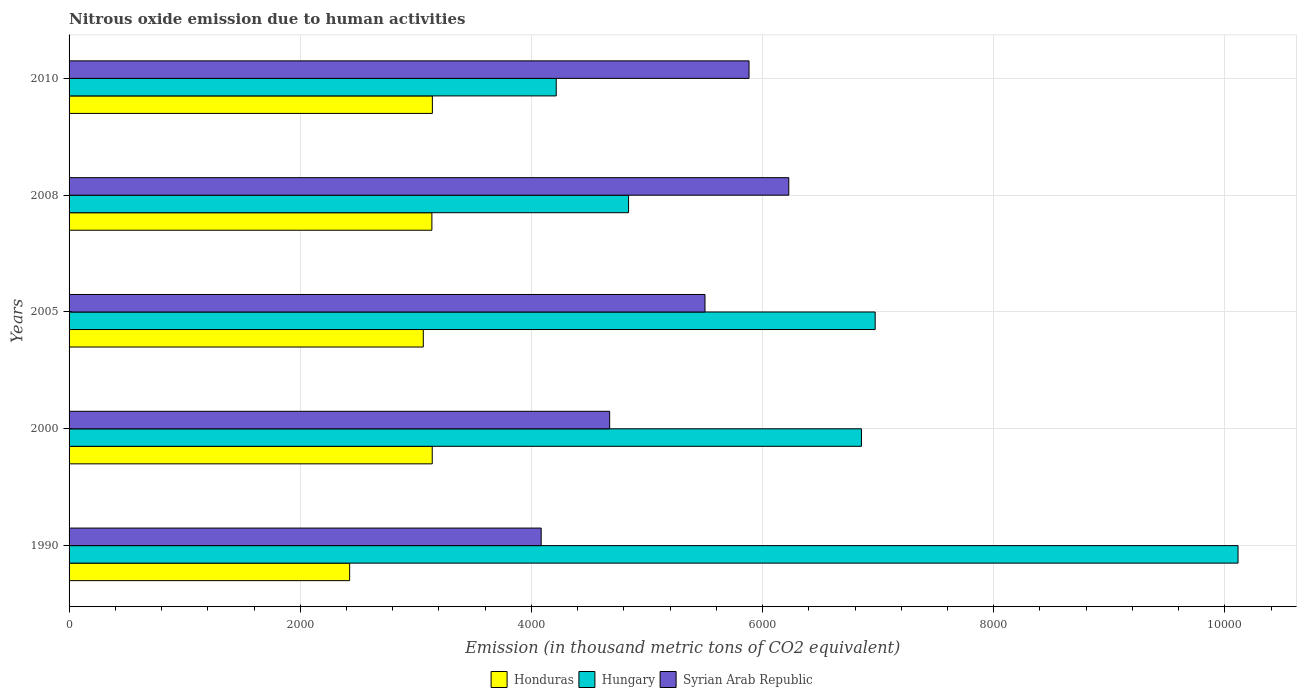How many different coloured bars are there?
Ensure brevity in your answer.  3. What is the label of the 2nd group of bars from the top?
Your answer should be very brief. 2008. What is the amount of nitrous oxide emitted in Honduras in 2000?
Give a very brief answer. 3142.2. Across all years, what is the maximum amount of nitrous oxide emitted in Hungary?
Your answer should be very brief. 1.01e+04. Across all years, what is the minimum amount of nitrous oxide emitted in Hungary?
Give a very brief answer. 4215.1. In which year was the amount of nitrous oxide emitted in Hungary minimum?
Keep it short and to the point. 2010. What is the total amount of nitrous oxide emitted in Honduras in the graph?
Provide a succinct answer. 1.49e+04. What is the difference between the amount of nitrous oxide emitted in Hungary in 1990 and that in 2008?
Give a very brief answer. 5273.4. What is the difference between the amount of nitrous oxide emitted in Hungary in 1990 and the amount of nitrous oxide emitted in Syrian Arab Republic in 2005?
Provide a short and direct response. 4612. What is the average amount of nitrous oxide emitted in Hungary per year?
Your response must be concise. 6600.1. In the year 2005, what is the difference between the amount of nitrous oxide emitted in Syrian Arab Republic and amount of nitrous oxide emitted in Hungary?
Provide a short and direct response. -1472.4. What is the ratio of the amount of nitrous oxide emitted in Honduras in 2000 to that in 2005?
Provide a short and direct response. 1.03. What is the difference between the highest and the second highest amount of nitrous oxide emitted in Honduras?
Offer a very short reply. 1.2. What is the difference between the highest and the lowest amount of nitrous oxide emitted in Syrian Arab Republic?
Ensure brevity in your answer.  2142.3. In how many years, is the amount of nitrous oxide emitted in Syrian Arab Republic greater than the average amount of nitrous oxide emitted in Syrian Arab Republic taken over all years?
Give a very brief answer. 3. Is the sum of the amount of nitrous oxide emitted in Syrian Arab Republic in 2000 and 2005 greater than the maximum amount of nitrous oxide emitted in Honduras across all years?
Make the answer very short. Yes. What does the 1st bar from the top in 2000 represents?
Offer a very short reply. Syrian Arab Republic. What does the 3rd bar from the bottom in 2005 represents?
Provide a succinct answer. Syrian Arab Republic. Are all the bars in the graph horizontal?
Your response must be concise. Yes. Are the values on the major ticks of X-axis written in scientific E-notation?
Keep it short and to the point. No. Does the graph contain any zero values?
Provide a succinct answer. No. Where does the legend appear in the graph?
Give a very brief answer. Bottom center. How many legend labels are there?
Make the answer very short. 3. What is the title of the graph?
Offer a terse response. Nitrous oxide emission due to human activities. Does "Bolivia" appear as one of the legend labels in the graph?
Keep it short and to the point. No. What is the label or title of the X-axis?
Provide a succinct answer. Emission (in thousand metric tons of CO2 equivalent). What is the Emission (in thousand metric tons of CO2 equivalent) in Honduras in 1990?
Your answer should be compact. 2427.6. What is the Emission (in thousand metric tons of CO2 equivalent) of Hungary in 1990?
Your response must be concise. 1.01e+04. What is the Emission (in thousand metric tons of CO2 equivalent) in Syrian Arab Republic in 1990?
Offer a terse response. 4084.8. What is the Emission (in thousand metric tons of CO2 equivalent) in Honduras in 2000?
Your answer should be compact. 3142.2. What is the Emission (in thousand metric tons of CO2 equivalent) of Hungary in 2000?
Provide a short and direct response. 6855.8. What is the Emission (in thousand metric tons of CO2 equivalent) of Syrian Arab Republic in 2000?
Provide a short and direct response. 4677.3. What is the Emission (in thousand metric tons of CO2 equivalent) in Honduras in 2005?
Keep it short and to the point. 3064.9. What is the Emission (in thousand metric tons of CO2 equivalent) of Hungary in 2005?
Offer a very short reply. 6974.6. What is the Emission (in thousand metric tons of CO2 equivalent) of Syrian Arab Republic in 2005?
Your answer should be compact. 5502.2. What is the Emission (in thousand metric tons of CO2 equivalent) of Honduras in 2008?
Give a very brief answer. 3139.2. What is the Emission (in thousand metric tons of CO2 equivalent) of Hungary in 2008?
Provide a succinct answer. 4840.8. What is the Emission (in thousand metric tons of CO2 equivalent) in Syrian Arab Republic in 2008?
Your answer should be compact. 6227.1. What is the Emission (in thousand metric tons of CO2 equivalent) of Honduras in 2010?
Your answer should be very brief. 3143.4. What is the Emission (in thousand metric tons of CO2 equivalent) in Hungary in 2010?
Offer a very short reply. 4215.1. What is the Emission (in thousand metric tons of CO2 equivalent) of Syrian Arab Republic in 2010?
Give a very brief answer. 5883.1. Across all years, what is the maximum Emission (in thousand metric tons of CO2 equivalent) of Honduras?
Give a very brief answer. 3143.4. Across all years, what is the maximum Emission (in thousand metric tons of CO2 equivalent) in Hungary?
Make the answer very short. 1.01e+04. Across all years, what is the maximum Emission (in thousand metric tons of CO2 equivalent) of Syrian Arab Republic?
Offer a terse response. 6227.1. Across all years, what is the minimum Emission (in thousand metric tons of CO2 equivalent) in Honduras?
Ensure brevity in your answer.  2427.6. Across all years, what is the minimum Emission (in thousand metric tons of CO2 equivalent) in Hungary?
Provide a succinct answer. 4215.1. Across all years, what is the minimum Emission (in thousand metric tons of CO2 equivalent) of Syrian Arab Republic?
Your answer should be very brief. 4084.8. What is the total Emission (in thousand metric tons of CO2 equivalent) in Honduras in the graph?
Provide a succinct answer. 1.49e+04. What is the total Emission (in thousand metric tons of CO2 equivalent) in Hungary in the graph?
Provide a short and direct response. 3.30e+04. What is the total Emission (in thousand metric tons of CO2 equivalent) of Syrian Arab Republic in the graph?
Give a very brief answer. 2.64e+04. What is the difference between the Emission (in thousand metric tons of CO2 equivalent) in Honduras in 1990 and that in 2000?
Give a very brief answer. -714.6. What is the difference between the Emission (in thousand metric tons of CO2 equivalent) of Hungary in 1990 and that in 2000?
Ensure brevity in your answer.  3258.4. What is the difference between the Emission (in thousand metric tons of CO2 equivalent) of Syrian Arab Republic in 1990 and that in 2000?
Your response must be concise. -592.5. What is the difference between the Emission (in thousand metric tons of CO2 equivalent) in Honduras in 1990 and that in 2005?
Provide a short and direct response. -637.3. What is the difference between the Emission (in thousand metric tons of CO2 equivalent) in Hungary in 1990 and that in 2005?
Your answer should be very brief. 3139.6. What is the difference between the Emission (in thousand metric tons of CO2 equivalent) of Syrian Arab Republic in 1990 and that in 2005?
Make the answer very short. -1417.4. What is the difference between the Emission (in thousand metric tons of CO2 equivalent) of Honduras in 1990 and that in 2008?
Your answer should be very brief. -711.6. What is the difference between the Emission (in thousand metric tons of CO2 equivalent) in Hungary in 1990 and that in 2008?
Your response must be concise. 5273.4. What is the difference between the Emission (in thousand metric tons of CO2 equivalent) of Syrian Arab Republic in 1990 and that in 2008?
Ensure brevity in your answer.  -2142.3. What is the difference between the Emission (in thousand metric tons of CO2 equivalent) in Honduras in 1990 and that in 2010?
Your response must be concise. -715.8. What is the difference between the Emission (in thousand metric tons of CO2 equivalent) in Hungary in 1990 and that in 2010?
Offer a very short reply. 5899.1. What is the difference between the Emission (in thousand metric tons of CO2 equivalent) in Syrian Arab Republic in 1990 and that in 2010?
Your response must be concise. -1798.3. What is the difference between the Emission (in thousand metric tons of CO2 equivalent) in Honduras in 2000 and that in 2005?
Make the answer very short. 77.3. What is the difference between the Emission (in thousand metric tons of CO2 equivalent) in Hungary in 2000 and that in 2005?
Keep it short and to the point. -118.8. What is the difference between the Emission (in thousand metric tons of CO2 equivalent) in Syrian Arab Republic in 2000 and that in 2005?
Provide a short and direct response. -824.9. What is the difference between the Emission (in thousand metric tons of CO2 equivalent) in Hungary in 2000 and that in 2008?
Your answer should be very brief. 2015. What is the difference between the Emission (in thousand metric tons of CO2 equivalent) of Syrian Arab Republic in 2000 and that in 2008?
Provide a succinct answer. -1549.8. What is the difference between the Emission (in thousand metric tons of CO2 equivalent) in Hungary in 2000 and that in 2010?
Offer a very short reply. 2640.7. What is the difference between the Emission (in thousand metric tons of CO2 equivalent) of Syrian Arab Republic in 2000 and that in 2010?
Offer a very short reply. -1205.8. What is the difference between the Emission (in thousand metric tons of CO2 equivalent) in Honduras in 2005 and that in 2008?
Offer a very short reply. -74.3. What is the difference between the Emission (in thousand metric tons of CO2 equivalent) in Hungary in 2005 and that in 2008?
Your answer should be very brief. 2133.8. What is the difference between the Emission (in thousand metric tons of CO2 equivalent) of Syrian Arab Republic in 2005 and that in 2008?
Provide a succinct answer. -724.9. What is the difference between the Emission (in thousand metric tons of CO2 equivalent) in Honduras in 2005 and that in 2010?
Ensure brevity in your answer.  -78.5. What is the difference between the Emission (in thousand metric tons of CO2 equivalent) in Hungary in 2005 and that in 2010?
Make the answer very short. 2759.5. What is the difference between the Emission (in thousand metric tons of CO2 equivalent) of Syrian Arab Republic in 2005 and that in 2010?
Ensure brevity in your answer.  -380.9. What is the difference between the Emission (in thousand metric tons of CO2 equivalent) of Honduras in 2008 and that in 2010?
Give a very brief answer. -4.2. What is the difference between the Emission (in thousand metric tons of CO2 equivalent) in Hungary in 2008 and that in 2010?
Provide a succinct answer. 625.7. What is the difference between the Emission (in thousand metric tons of CO2 equivalent) of Syrian Arab Republic in 2008 and that in 2010?
Provide a short and direct response. 344. What is the difference between the Emission (in thousand metric tons of CO2 equivalent) in Honduras in 1990 and the Emission (in thousand metric tons of CO2 equivalent) in Hungary in 2000?
Your answer should be compact. -4428.2. What is the difference between the Emission (in thousand metric tons of CO2 equivalent) in Honduras in 1990 and the Emission (in thousand metric tons of CO2 equivalent) in Syrian Arab Republic in 2000?
Your response must be concise. -2249.7. What is the difference between the Emission (in thousand metric tons of CO2 equivalent) in Hungary in 1990 and the Emission (in thousand metric tons of CO2 equivalent) in Syrian Arab Republic in 2000?
Keep it short and to the point. 5436.9. What is the difference between the Emission (in thousand metric tons of CO2 equivalent) in Honduras in 1990 and the Emission (in thousand metric tons of CO2 equivalent) in Hungary in 2005?
Offer a terse response. -4547. What is the difference between the Emission (in thousand metric tons of CO2 equivalent) in Honduras in 1990 and the Emission (in thousand metric tons of CO2 equivalent) in Syrian Arab Republic in 2005?
Your response must be concise. -3074.6. What is the difference between the Emission (in thousand metric tons of CO2 equivalent) in Hungary in 1990 and the Emission (in thousand metric tons of CO2 equivalent) in Syrian Arab Republic in 2005?
Offer a very short reply. 4612. What is the difference between the Emission (in thousand metric tons of CO2 equivalent) in Honduras in 1990 and the Emission (in thousand metric tons of CO2 equivalent) in Hungary in 2008?
Keep it short and to the point. -2413.2. What is the difference between the Emission (in thousand metric tons of CO2 equivalent) of Honduras in 1990 and the Emission (in thousand metric tons of CO2 equivalent) of Syrian Arab Republic in 2008?
Give a very brief answer. -3799.5. What is the difference between the Emission (in thousand metric tons of CO2 equivalent) in Hungary in 1990 and the Emission (in thousand metric tons of CO2 equivalent) in Syrian Arab Republic in 2008?
Keep it short and to the point. 3887.1. What is the difference between the Emission (in thousand metric tons of CO2 equivalent) in Honduras in 1990 and the Emission (in thousand metric tons of CO2 equivalent) in Hungary in 2010?
Give a very brief answer. -1787.5. What is the difference between the Emission (in thousand metric tons of CO2 equivalent) in Honduras in 1990 and the Emission (in thousand metric tons of CO2 equivalent) in Syrian Arab Republic in 2010?
Offer a terse response. -3455.5. What is the difference between the Emission (in thousand metric tons of CO2 equivalent) in Hungary in 1990 and the Emission (in thousand metric tons of CO2 equivalent) in Syrian Arab Republic in 2010?
Ensure brevity in your answer.  4231.1. What is the difference between the Emission (in thousand metric tons of CO2 equivalent) in Honduras in 2000 and the Emission (in thousand metric tons of CO2 equivalent) in Hungary in 2005?
Keep it short and to the point. -3832.4. What is the difference between the Emission (in thousand metric tons of CO2 equivalent) of Honduras in 2000 and the Emission (in thousand metric tons of CO2 equivalent) of Syrian Arab Republic in 2005?
Keep it short and to the point. -2360. What is the difference between the Emission (in thousand metric tons of CO2 equivalent) of Hungary in 2000 and the Emission (in thousand metric tons of CO2 equivalent) of Syrian Arab Republic in 2005?
Keep it short and to the point. 1353.6. What is the difference between the Emission (in thousand metric tons of CO2 equivalent) in Honduras in 2000 and the Emission (in thousand metric tons of CO2 equivalent) in Hungary in 2008?
Your answer should be very brief. -1698.6. What is the difference between the Emission (in thousand metric tons of CO2 equivalent) of Honduras in 2000 and the Emission (in thousand metric tons of CO2 equivalent) of Syrian Arab Republic in 2008?
Your response must be concise. -3084.9. What is the difference between the Emission (in thousand metric tons of CO2 equivalent) in Hungary in 2000 and the Emission (in thousand metric tons of CO2 equivalent) in Syrian Arab Republic in 2008?
Your answer should be very brief. 628.7. What is the difference between the Emission (in thousand metric tons of CO2 equivalent) in Honduras in 2000 and the Emission (in thousand metric tons of CO2 equivalent) in Hungary in 2010?
Keep it short and to the point. -1072.9. What is the difference between the Emission (in thousand metric tons of CO2 equivalent) in Honduras in 2000 and the Emission (in thousand metric tons of CO2 equivalent) in Syrian Arab Republic in 2010?
Your answer should be compact. -2740.9. What is the difference between the Emission (in thousand metric tons of CO2 equivalent) in Hungary in 2000 and the Emission (in thousand metric tons of CO2 equivalent) in Syrian Arab Republic in 2010?
Make the answer very short. 972.7. What is the difference between the Emission (in thousand metric tons of CO2 equivalent) in Honduras in 2005 and the Emission (in thousand metric tons of CO2 equivalent) in Hungary in 2008?
Make the answer very short. -1775.9. What is the difference between the Emission (in thousand metric tons of CO2 equivalent) in Honduras in 2005 and the Emission (in thousand metric tons of CO2 equivalent) in Syrian Arab Republic in 2008?
Ensure brevity in your answer.  -3162.2. What is the difference between the Emission (in thousand metric tons of CO2 equivalent) of Hungary in 2005 and the Emission (in thousand metric tons of CO2 equivalent) of Syrian Arab Republic in 2008?
Provide a short and direct response. 747.5. What is the difference between the Emission (in thousand metric tons of CO2 equivalent) of Honduras in 2005 and the Emission (in thousand metric tons of CO2 equivalent) of Hungary in 2010?
Provide a succinct answer. -1150.2. What is the difference between the Emission (in thousand metric tons of CO2 equivalent) of Honduras in 2005 and the Emission (in thousand metric tons of CO2 equivalent) of Syrian Arab Republic in 2010?
Offer a terse response. -2818.2. What is the difference between the Emission (in thousand metric tons of CO2 equivalent) in Hungary in 2005 and the Emission (in thousand metric tons of CO2 equivalent) in Syrian Arab Republic in 2010?
Provide a succinct answer. 1091.5. What is the difference between the Emission (in thousand metric tons of CO2 equivalent) in Honduras in 2008 and the Emission (in thousand metric tons of CO2 equivalent) in Hungary in 2010?
Your answer should be compact. -1075.9. What is the difference between the Emission (in thousand metric tons of CO2 equivalent) in Honduras in 2008 and the Emission (in thousand metric tons of CO2 equivalent) in Syrian Arab Republic in 2010?
Give a very brief answer. -2743.9. What is the difference between the Emission (in thousand metric tons of CO2 equivalent) in Hungary in 2008 and the Emission (in thousand metric tons of CO2 equivalent) in Syrian Arab Republic in 2010?
Provide a succinct answer. -1042.3. What is the average Emission (in thousand metric tons of CO2 equivalent) in Honduras per year?
Offer a very short reply. 2983.46. What is the average Emission (in thousand metric tons of CO2 equivalent) of Hungary per year?
Your response must be concise. 6600.1. What is the average Emission (in thousand metric tons of CO2 equivalent) in Syrian Arab Republic per year?
Ensure brevity in your answer.  5274.9. In the year 1990, what is the difference between the Emission (in thousand metric tons of CO2 equivalent) in Honduras and Emission (in thousand metric tons of CO2 equivalent) in Hungary?
Ensure brevity in your answer.  -7686.6. In the year 1990, what is the difference between the Emission (in thousand metric tons of CO2 equivalent) in Honduras and Emission (in thousand metric tons of CO2 equivalent) in Syrian Arab Republic?
Your response must be concise. -1657.2. In the year 1990, what is the difference between the Emission (in thousand metric tons of CO2 equivalent) in Hungary and Emission (in thousand metric tons of CO2 equivalent) in Syrian Arab Republic?
Keep it short and to the point. 6029.4. In the year 2000, what is the difference between the Emission (in thousand metric tons of CO2 equivalent) in Honduras and Emission (in thousand metric tons of CO2 equivalent) in Hungary?
Provide a succinct answer. -3713.6. In the year 2000, what is the difference between the Emission (in thousand metric tons of CO2 equivalent) of Honduras and Emission (in thousand metric tons of CO2 equivalent) of Syrian Arab Republic?
Offer a very short reply. -1535.1. In the year 2000, what is the difference between the Emission (in thousand metric tons of CO2 equivalent) of Hungary and Emission (in thousand metric tons of CO2 equivalent) of Syrian Arab Republic?
Your response must be concise. 2178.5. In the year 2005, what is the difference between the Emission (in thousand metric tons of CO2 equivalent) of Honduras and Emission (in thousand metric tons of CO2 equivalent) of Hungary?
Ensure brevity in your answer.  -3909.7. In the year 2005, what is the difference between the Emission (in thousand metric tons of CO2 equivalent) in Honduras and Emission (in thousand metric tons of CO2 equivalent) in Syrian Arab Republic?
Offer a terse response. -2437.3. In the year 2005, what is the difference between the Emission (in thousand metric tons of CO2 equivalent) of Hungary and Emission (in thousand metric tons of CO2 equivalent) of Syrian Arab Republic?
Your answer should be compact. 1472.4. In the year 2008, what is the difference between the Emission (in thousand metric tons of CO2 equivalent) in Honduras and Emission (in thousand metric tons of CO2 equivalent) in Hungary?
Keep it short and to the point. -1701.6. In the year 2008, what is the difference between the Emission (in thousand metric tons of CO2 equivalent) in Honduras and Emission (in thousand metric tons of CO2 equivalent) in Syrian Arab Republic?
Give a very brief answer. -3087.9. In the year 2008, what is the difference between the Emission (in thousand metric tons of CO2 equivalent) in Hungary and Emission (in thousand metric tons of CO2 equivalent) in Syrian Arab Republic?
Your answer should be very brief. -1386.3. In the year 2010, what is the difference between the Emission (in thousand metric tons of CO2 equivalent) of Honduras and Emission (in thousand metric tons of CO2 equivalent) of Hungary?
Your answer should be compact. -1071.7. In the year 2010, what is the difference between the Emission (in thousand metric tons of CO2 equivalent) of Honduras and Emission (in thousand metric tons of CO2 equivalent) of Syrian Arab Republic?
Provide a succinct answer. -2739.7. In the year 2010, what is the difference between the Emission (in thousand metric tons of CO2 equivalent) of Hungary and Emission (in thousand metric tons of CO2 equivalent) of Syrian Arab Republic?
Keep it short and to the point. -1668. What is the ratio of the Emission (in thousand metric tons of CO2 equivalent) of Honduras in 1990 to that in 2000?
Ensure brevity in your answer.  0.77. What is the ratio of the Emission (in thousand metric tons of CO2 equivalent) of Hungary in 1990 to that in 2000?
Your answer should be very brief. 1.48. What is the ratio of the Emission (in thousand metric tons of CO2 equivalent) of Syrian Arab Republic in 1990 to that in 2000?
Provide a succinct answer. 0.87. What is the ratio of the Emission (in thousand metric tons of CO2 equivalent) of Honduras in 1990 to that in 2005?
Provide a succinct answer. 0.79. What is the ratio of the Emission (in thousand metric tons of CO2 equivalent) in Hungary in 1990 to that in 2005?
Your answer should be compact. 1.45. What is the ratio of the Emission (in thousand metric tons of CO2 equivalent) of Syrian Arab Republic in 1990 to that in 2005?
Make the answer very short. 0.74. What is the ratio of the Emission (in thousand metric tons of CO2 equivalent) in Honduras in 1990 to that in 2008?
Make the answer very short. 0.77. What is the ratio of the Emission (in thousand metric tons of CO2 equivalent) in Hungary in 1990 to that in 2008?
Your answer should be very brief. 2.09. What is the ratio of the Emission (in thousand metric tons of CO2 equivalent) in Syrian Arab Republic in 1990 to that in 2008?
Provide a short and direct response. 0.66. What is the ratio of the Emission (in thousand metric tons of CO2 equivalent) of Honduras in 1990 to that in 2010?
Ensure brevity in your answer.  0.77. What is the ratio of the Emission (in thousand metric tons of CO2 equivalent) in Hungary in 1990 to that in 2010?
Your response must be concise. 2.4. What is the ratio of the Emission (in thousand metric tons of CO2 equivalent) in Syrian Arab Republic in 1990 to that in 2010?
Offer a terse response. 0.69. What is the ratio of the Emission (in thousand metric tons of CO2 equivalent) of Honduras in 2000 to that in 2005?
Your response must be concise. 1.03. What is the ratio of the Emission (in thousand metric tons of CO2 equivalent) of Hungary in 2000 to that in 2005?
Offer a very short reply. 0.98. What is the ratio of the Emission (in thousand metric tons of CO2 equivalent) in Syrian Arab Republic in 2000 to that in 2005?
Give a very brief answer. 0.85. What is the ratio of the Emission (in thousand metric tons of CO2 equivalent) of Honduras in 2000 to that in 2008?
Provide a succinct answer. 1. What is the ratio of the Emission (in thousand metric tons of CO2 equivalent) in Hungary in 2000 to that in 2008?
Keep it short and to the point. 1.42. What is the ratio of the Emission (in thousand metric tons of CO2 equivalent) of Syrian Arab Republic in 2000 to that in 2008?
Keep it short and to the point. 0.75. What is the ratio of the Emission (in thousand metric tons of CO2 equivalent) in Hungary in 2000 to that in 2010?
Your response must be concise. 1.63. What is the ratio of the Emission (in thousand metric tons of CO2 equivalent) in Syrian Arab Republic in 2000 to that in 2010?
Offer a terse response. 0.8. What is the ratio of the Emission (in thousand metric tons of CO2 equivalent) in Honduras in 2005 to that in 2008?
Give a very brief answer. 0.98. What is the ratio of the Emission (in thousand metric tons of CO2 equivalent) of Hungary in 2005 to that in 2008?
Your answer should be compact. 1.44. What is the ratio of the Emission (in thousand metric tons of CO2 equivalent) of Syrian Arab Republic in 2005 to that in 2008?
Provide a succinct answer. 0.88. What is the ratio of the Emission (in thousand metric tons of CO2 equivalent) in Honduras in 2005 to that in 2010?
Your answer should be compact. 0.97. What is the ratio of the Emission (in thousand metric tons of CO2 equivalent) in Hungary in 2005 to that in 2010?
Offer a terse response. 1.65. What is the ratio of the Emission (in thousand metric tons of CO2 equivalent) in Syrian Arab Republic in 2005 to that in 2010?
Your answer should be compact. 0.94. What is the ratio of the Emission (in thousand metric tons of CO2 equivalent) of Honduras in 2008 to that in 2010?
Ensure brevity in your answer.  1. What is the ratio of the Emission (in thousand metric tons of CO2 equivalent) in Hungary in 2008 to that in 2010?
Your response must be concise. 1.15. What is the ratio of the Emission (in thousand metric tons of CO2 equivalent) of Syrian Arab Republic in 2008 to that in 2010?
Keep it short and to the point. 1.06. What is the difference between the highest and the second highest Emission (in thousand metric tons of CO2 equivalent) of Hungary?
Keep it short and to the point. 3139.6. What is the difference between the highest and the second highest Emission (in thousand metric tons of CO2 equivalent) of Syrian Arab Republic?
Make the answer very short. 344. What is the difference between the highest and the lowest Emission (in thousand metric tons of CO2 equivalent) of Honduras?
Your answer should be very brief. 715.8. What is the difference between the highest and the lowest Emission (in thousand metric tons of CO2 equivalent) in Hungary?
Ensure brevity in your answer.  5899.1. What is the difference between the highest and the lowest Emission (in thousand metric tons of CO2 equivalent) in Syrian Arab Republic?
Keep it short and to the point. 2142.3. 